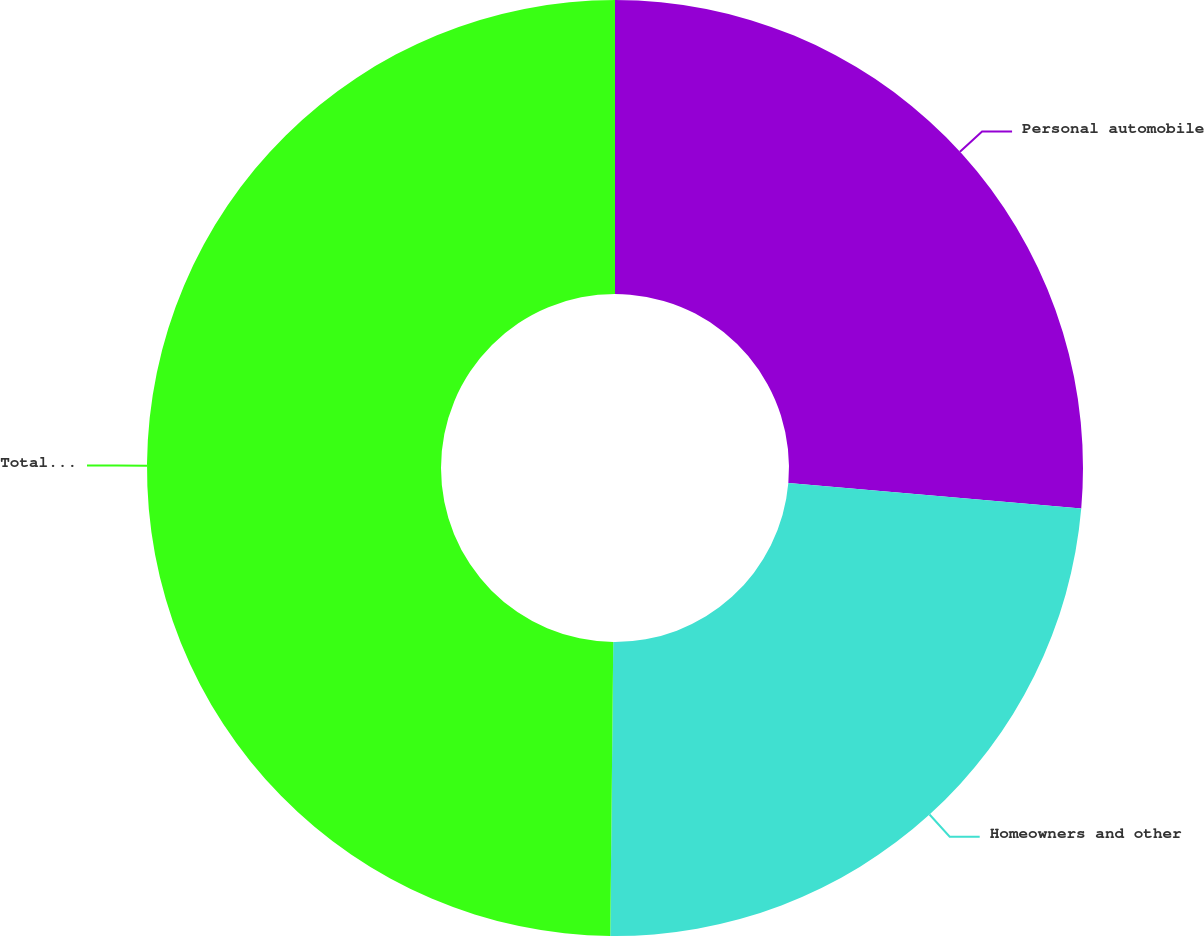<chart> <loc_0><loc_0><loc_500><loc_500><pie_chart><fcel>Personal automobile<fcel>Homeowners and other<fcel>Total Personal Insurance<nl><fcel>26.38%<fcel>23.78%<fcel>49.84%<nl></chart> 